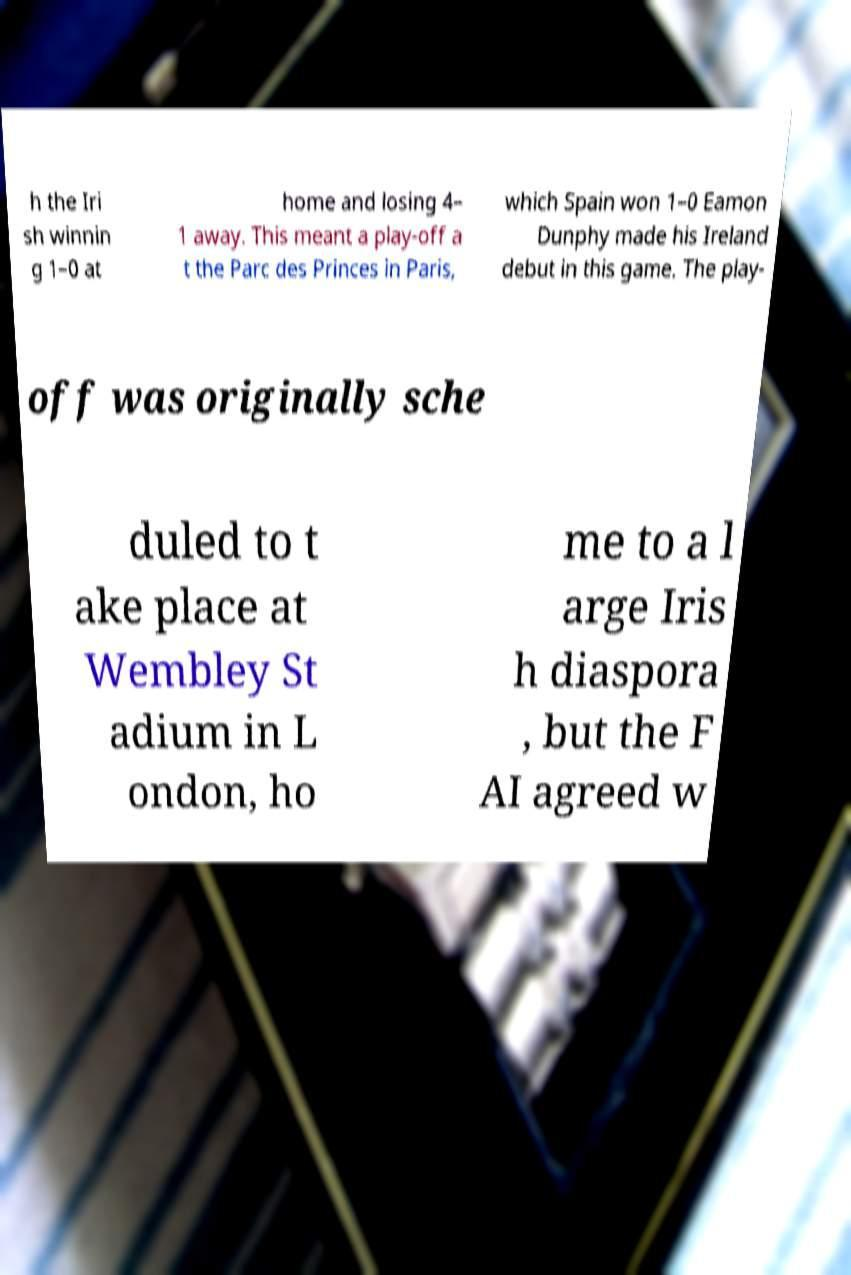Could you extract and type out the text from this image? h the Iri sh winnin g 1–0 at home and losing 4– 1 away. This meant a play-off a t the Parc des Princes in Paris, which Spain won 1–0 Eamon Dunphy made his Ireland debut in this game. The play- off was originally sche duled to t ake place at Wembley St adium in L ondon, ho me to a l arge Iris h diaspora , but the F AI agreed w 